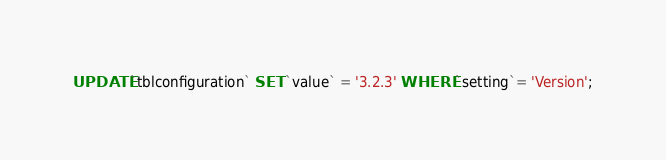<code> <loc_0><loc_0><loc_500><loc_500><_SQL_>UPDATE `tblconfiguration` SET `value` = '3.2.3' WHERE `setting`= 'Version';
</code> 